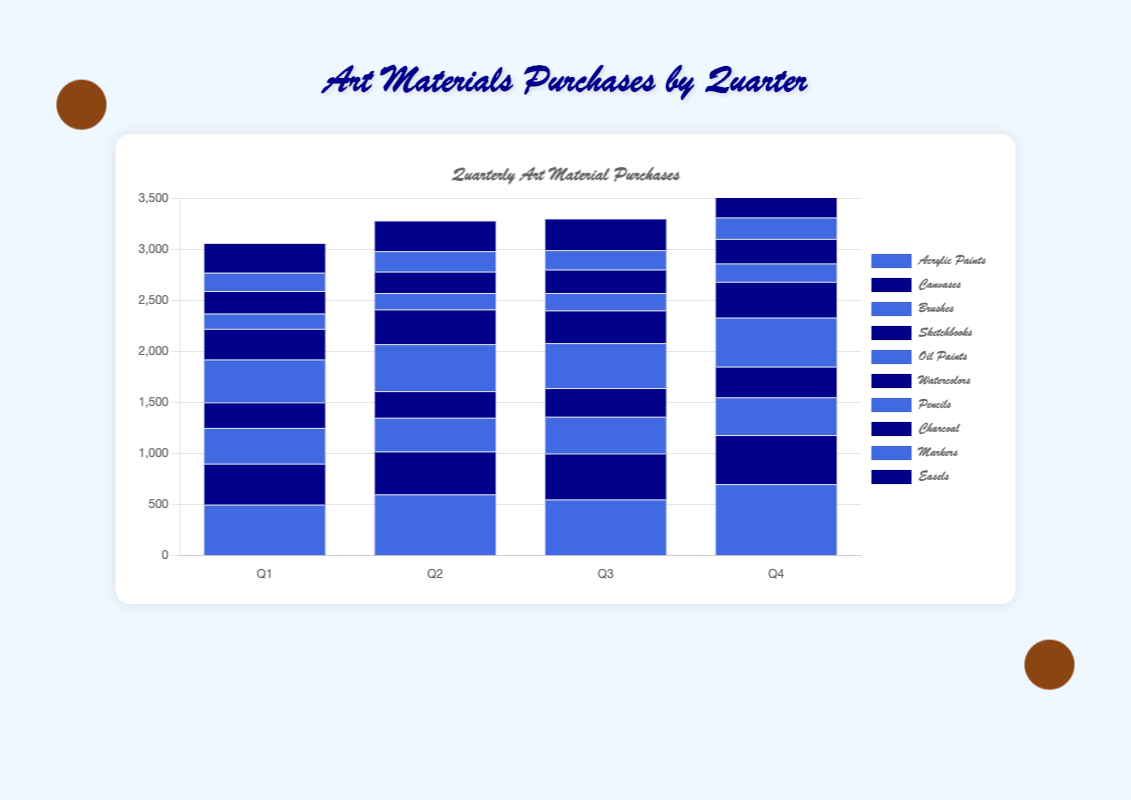What's the total cost of Acrylic Paints and Oil Paints in Q3? In Q3, the cost of Acrylic Paints is 550 and the cost of Oil Paints is 440. Summing these values gives 550 + 440 = 990.
Answer: 990 Which quarter saw the highest purchase of Brushes? By comparing the heights of the bars representing Brushes across all four quarters, Q4 has the highest bar with a cost of 370.
Answer: Q4 How does the cost of Sketchbooks in Q4 compare to that of Markers in the same quarter? The cost of Sketchbooks in Q4 is 300, while the cost of Markers in Q4 is 210. Since 300 is greater than 210, Sketchbooks cost more in Q4.
Answer: Sketchbooks cost more What is the average cost of Canvases per quarter? Sum the values for Canvases over all quarters: 400 + 420 + 450 + 480 = 1750. Then divide by the number of quarters, 1750 / 4 = 437.5.
Answer: 437.5 Are Watercolors or Charcoal purchased more in Q2? In Q2, the cost of Watercolors is 340 and the cost of Charcoal is 210. Since 340 is greater than 210, Watercolors were purchased more in Q2.
Answer: Watercolors Which art material has the lowest purchase cost in Q1? By comparing the bars for all art materials in Q1, Pencils have the lowest bar with a cost of 150.
Answer: Pencils What's the total cost of all art materials in Q1? Sum the costs of all art materials in Q1: 500 + 400 + 350 + 250 + 420 + 300 + 150 + 220 + 180 + 290. The total is 3060.
Answer: 3060 How much more was spent on Easels in Q4 compared to Q1? The cost of Easels in Q4 is 320, and the cost in Q1 is 290. The difference is 320 - 290 = 30.
Answer: 30 Which art materials show a consistent increase in cost from Q1 to Q4? By examining the heights of the bars from Q1 to Q4 for each art material, Acrylic Paints, Canvases, Sketchbooks, Pencils, and Easels all show consistent increases.
Answer: Acrylic Paints, Canvases, Sketchbooks, Pencils, Easels 